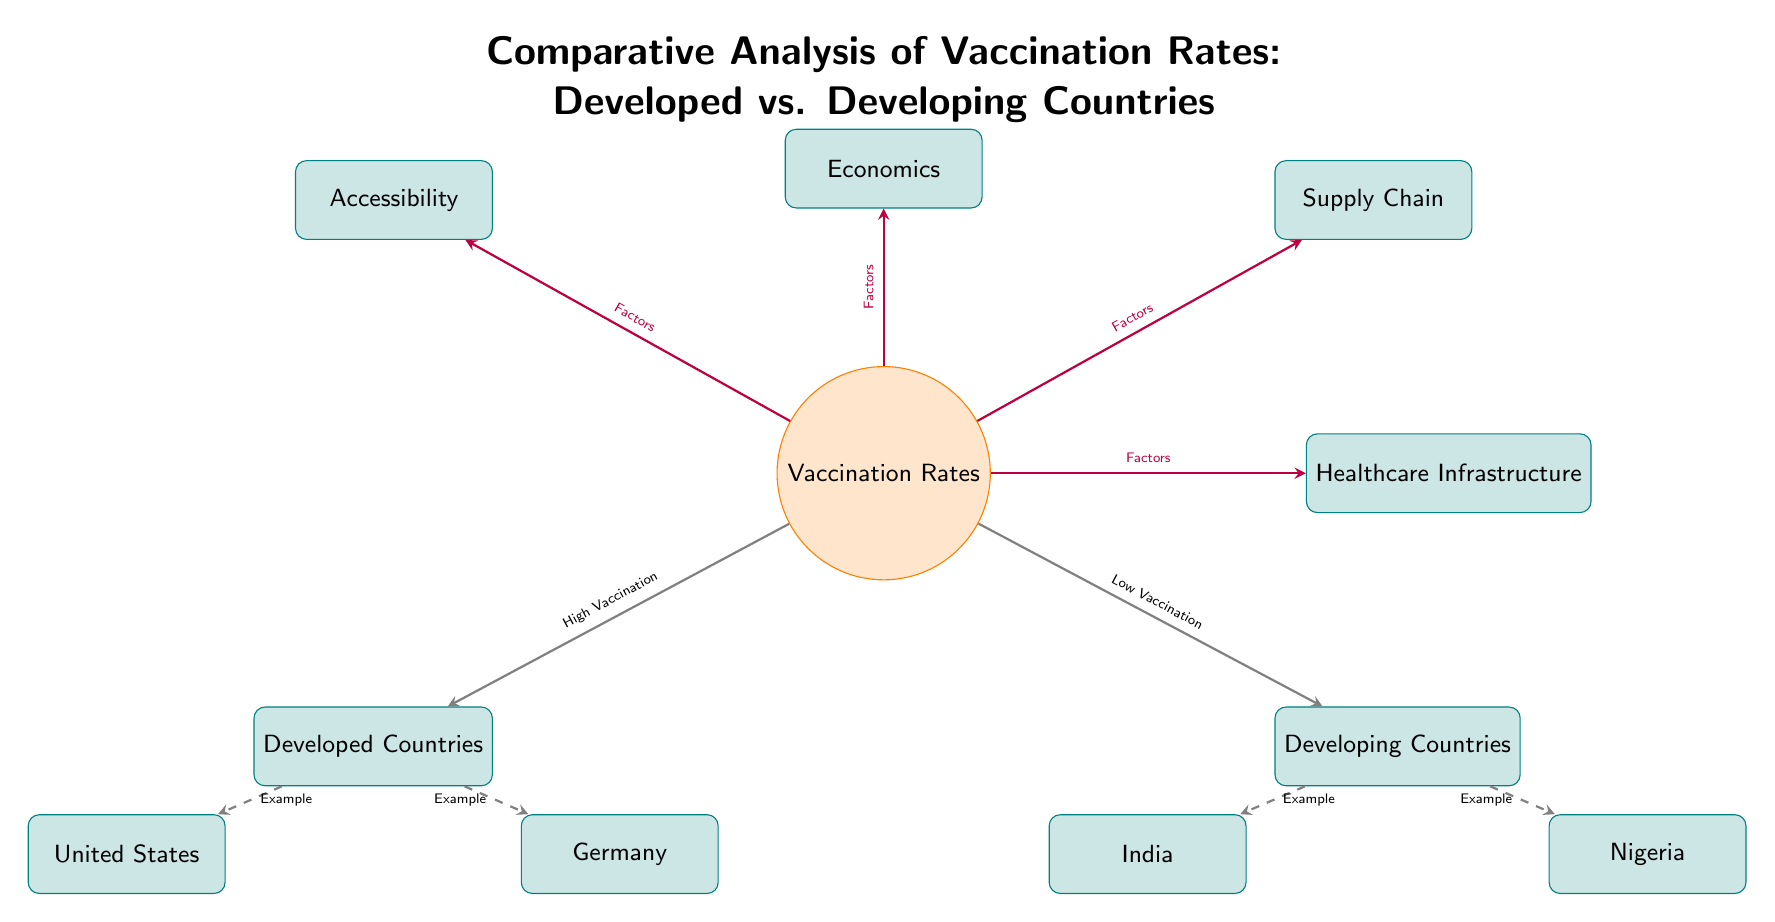What are the two main categories of vaccination rates depicted in the diagram? The diagram has two main categories of vaccination rates: Developed Countries and Developing Countries, which are positioned on opposite sides of the central node labeled Vaccination Rates.
Answer: Developed Countries, Developing Countries How many example countries are provided for Developing Countries? The diagram lists two example countries specifically for Developing Countries: India and Nigeria, indicated under that category.
Answer: 2 What factor is positioned directly above the Vaccination Rates node? The diagram shows Economics as the factor positioned directly above the central Vaccination Rates node, highlighting its significance.
Answer: Economics Which node describes the type of healthcare systems in relation to vaccination rates? The node labeled Healthcare Infrastructure is aligned to the right of the central node and describes its role in vaccination rates, linking it as a contributing factor.
Answer: Healthcare Infrastructure How does the diagram illustrate the difference in vaccination rates? The diagram uses arrows to indicate a high vaccination rate pointing towards Developed Countries and a low vaccination rate towards Developing Countries, clearly showing the comparative nature of vaccination distribution.
Answer: High Vaccination, Low Vaccination What color represents the nodes for Developed Countries? The nodes representing Developed Countries are in a teal color, as indicated by the fill specifications in the diagram's design.
Answer: Teal Why might the factor "Supply Chain" be important in the context of this diagram? Supply Chain is listed as a factor that influences Vaccination Rates, suggesting that efficient logistics and distribution mechanisms are crucial for ensuring vaccine availability, especially in developing countries.
Answer: Important for vaccine availability Are all nodes and factors directly connected with arrows in the diagram? Yes, all nodes and factors related to Vaccination Rates are interconnected with arrows, indicating the relationships and influences between them in the context of the analysis.
Answer: Yes 